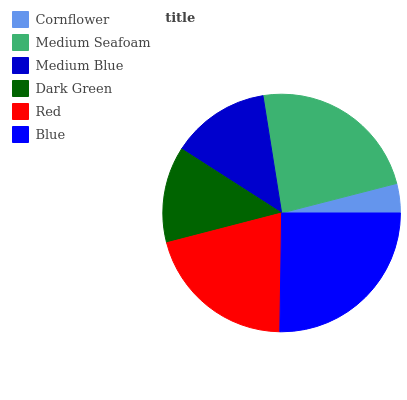Is Cornflower the minimum?
Answer yes or no. Yes. Is Blue the maximum?
Answer yes or no. Yes. Is Medium Seafoam the minimum?
Answer yes or no. No. Is Medium Seafoam the maximum?
Answer yes or no. No. Is Medium Seafoam greater than Cornflower?
Answer yes or no. Yes. Is Cornflower less than Medium Seafoam?
Answer yes or no. Yes. Is Cornflower greater than Medium Seafoam?
Answer yes or no. No. Is Medium Seafoam less than Cornflower?
Answer yes or no. No. Is Red the high median?
Answer yes or no. Yes. Is Medium Blue the low median?
Answer yes or no. Yes. Is Medium Seafoam the high median?
Answer yes or no. No. Is Medium Seafoam the low median?
Answer yes or no. No. 